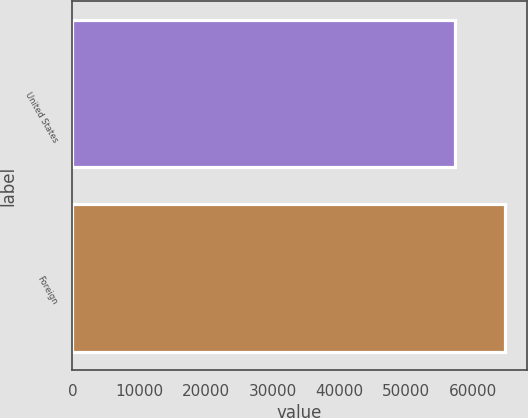Convert chart. <chart><loc_0><loc_0><loc_500><loc_500><bar_chart><fcel>United States<fcel>Foreign<nl><fcel>57335<fcel>64889<nl></chart> 